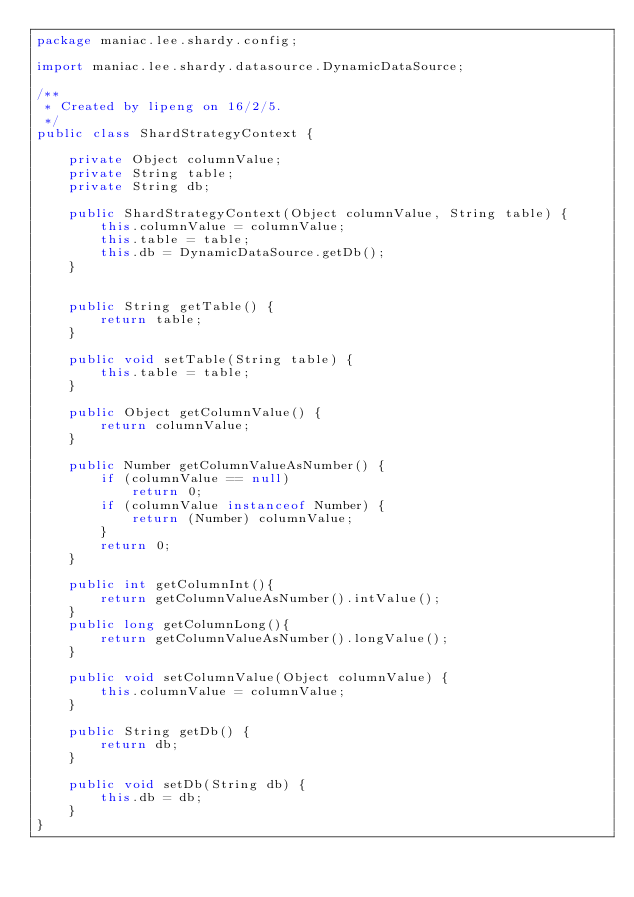<code> <loc_0><loc_0><loc_500><loc_500><_Java_>package maniac.lee.shardy.config;

import maniac.lee.shardy.datasource.DynamicDataSource;

/**
 * Created by lipeng on 16/2/5.
 */
public class ShardStrategyContext {

    private Object columnValue;
    private String table;
    private String db;

    public ShardStrategyContext(Object columnValue, String table) {
        this.columnValue = columnValue;
        this.table = table;
        this.db = DynamicDataSource.getDb();
    }


    public String getTable() {
        return table;
    }

    public void setTable(String table) {
        this.table = table;
    }

    public Object getColumnValue() {
        return columnValue;
    }

    public Number getColumnValueAsNumber() {
        if (columnValue == null)
            return 0;
        if (columnValue instanceof Number) {
            return (Number) columnValue;
        }
        return 0;
    }

    public int getColumnInt(){
        return getColumnValueAsNumber().intValue();
    }
    public long getColumnLong(){
        return getColumnValueAsNumber().longValue();
    }

    public void setColumnValue(Object columnValue) {
        this.columnValue = columnValue;
    }

    public String getDb() {
        return db;
    }

    public void setDb(String db) {
        this.db = db;
    }
}
</code> 